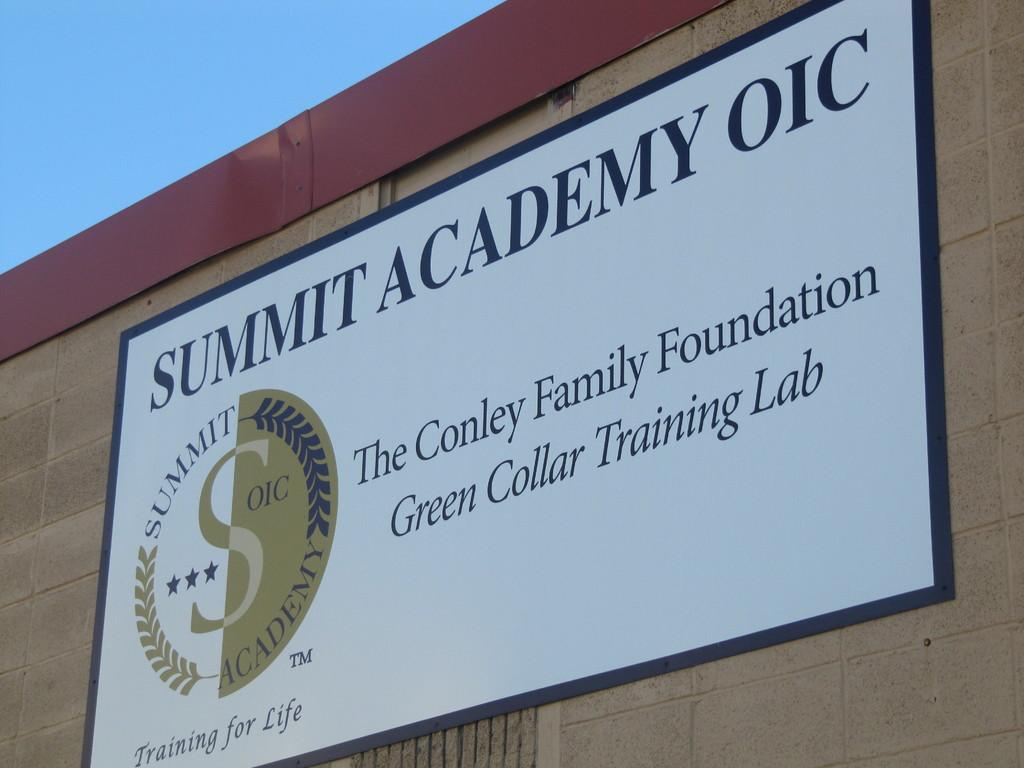<image>
Give a short and clear explanation of the subsequent image. Big sign that says Summit Academy OIC with a Summit OIC Academy logo. 